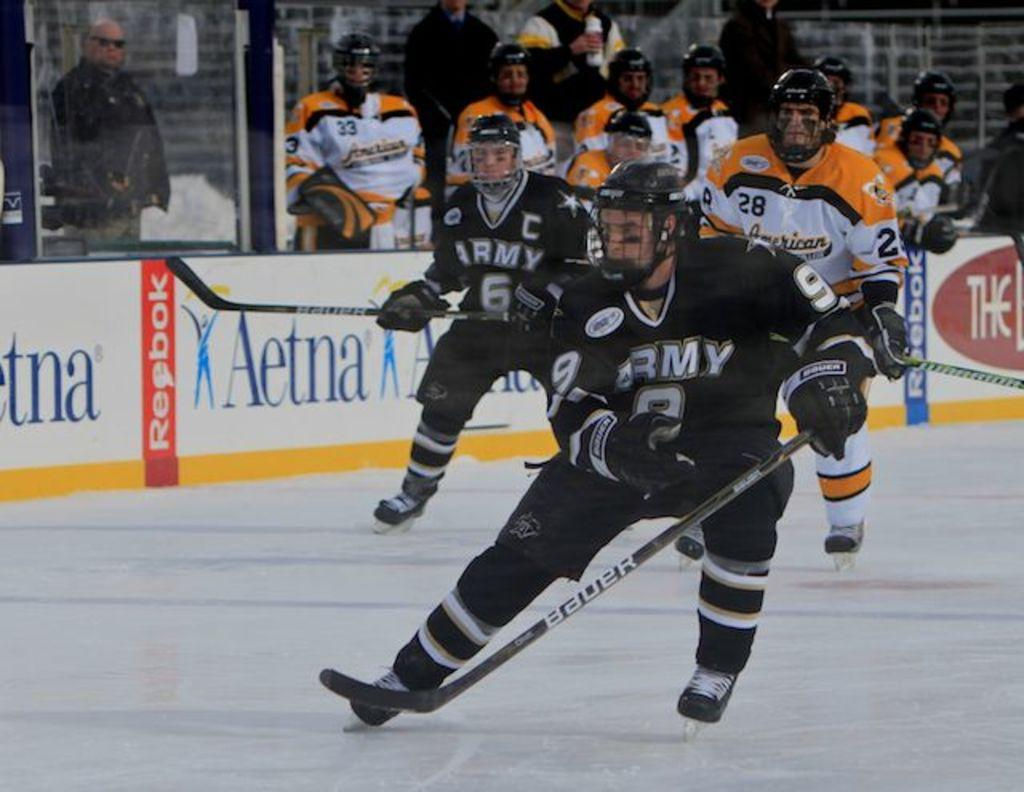<image>
Render a clear and concise summary of the photo. An Ice hockey player wearing black and with the word Army on his front skates on the ice in front of adverts for Reebok and Aetna 